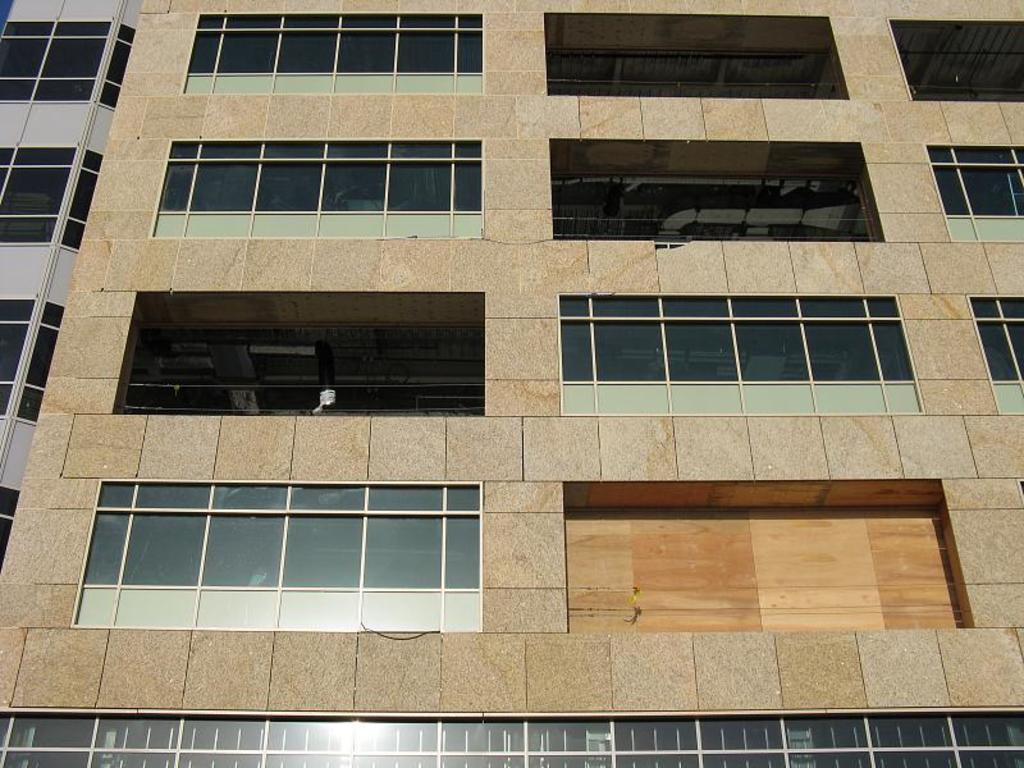What type of structure is present in the image? There is a building in the image. What feature can be observed on the building? The building has glass windows. Can you describe the building on the left side of the image? The building on the left side is in white and black color. What type of blade is being used by the person skating on the line in the image? There is no person skating on a line or using a blade in the image; it only features two buildings. 